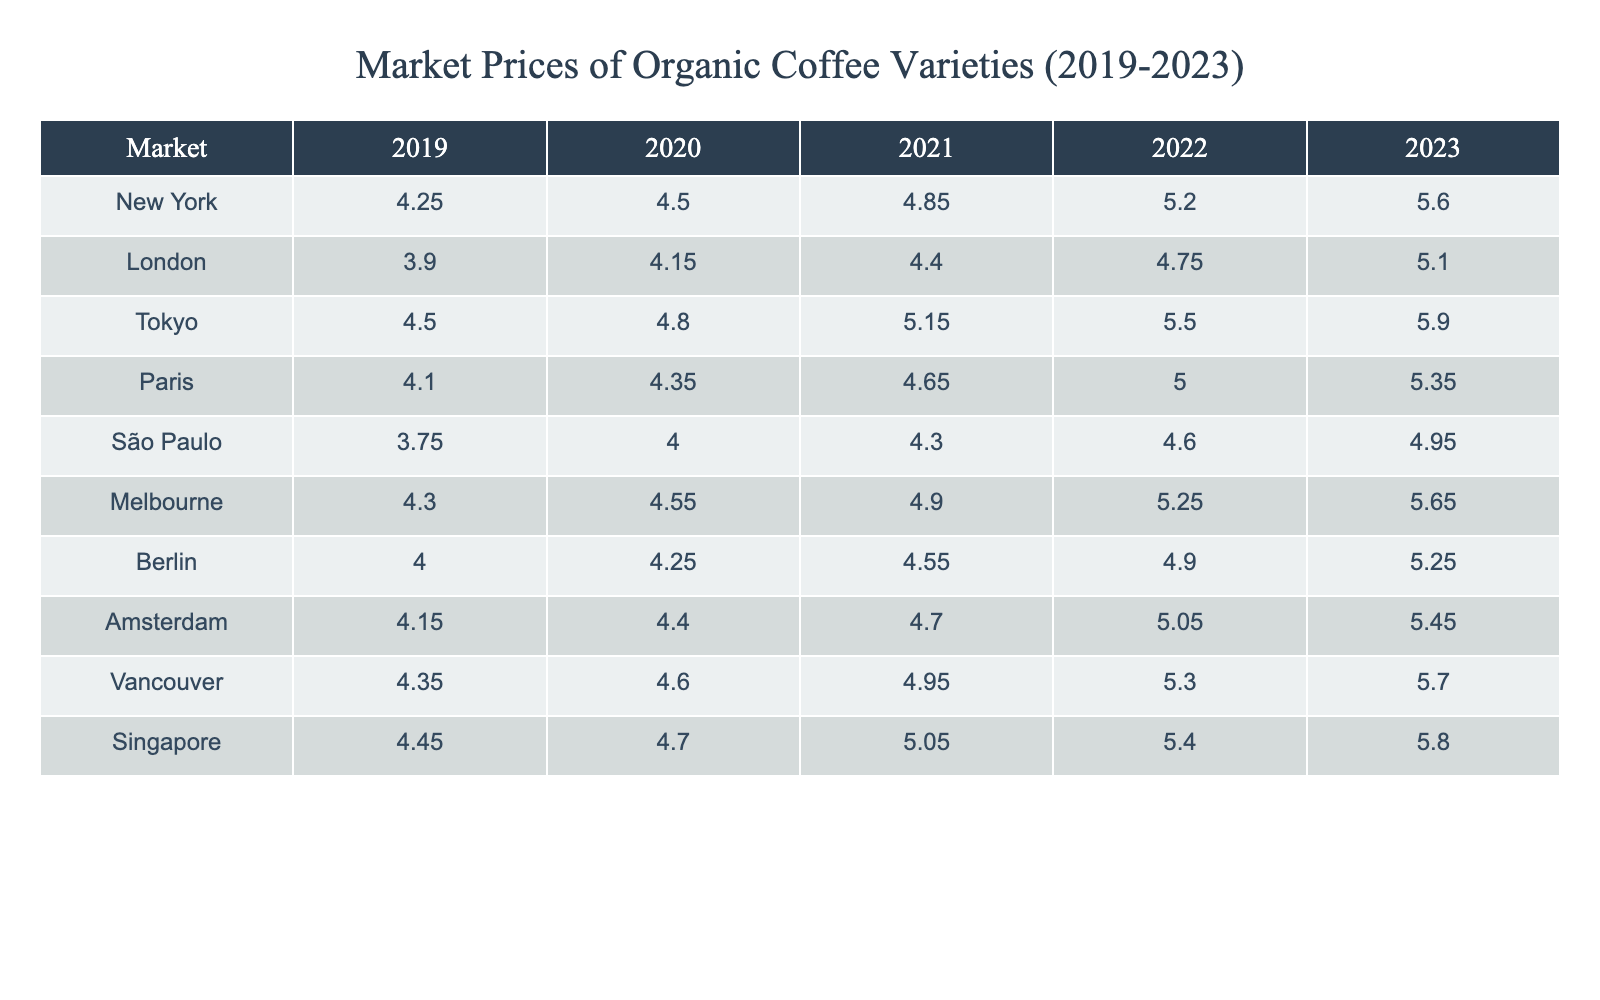What was the market price of organic coffee in New York in 2021? The table shows that the price of organic coffee in New York for the year 2021 is 4.85.
Answer: 4.85 Which market had the highest price for organic coffee in 2023? Looking at the prices for 2023, Tokyo has the highest price at 5.90.
Answer: Tokyo What was the average price of organic coffee in London over the past 5 years? To find the average, sum the prices: (3.90 + 4.15 + 4.40 + 4.75 + 5.10) = 22.30. Then divide by 5: 22.30/5 = 4.46.
Answer: 4.46 Was the price of organic coffee in São Paulo higher in 2022 compared to 2021? The price in 2022 was 4.60 and in 2021 was 4.30. Since 4.60 is greater than 4.30, the statement is true.
Answer: Yes What was the percentage increase in the price of organic coffee in Tokyo from 2019 to 2023? Calculate the increase: 5.90 - 4.50 = 1.40. Then divide by the 2019 price: 1.40/4.50 ≈ 0.3111. Multiply by 100 for percentage: 0.3111 * 100 ≈ 31.11%.
Answer: 31.11% In which year did Berlin see a price of organic coffee below 4.60? The prices for Berlin were 4.00 in 2019, 4.25 in 2020, and 4.55 in 2021, all of which are below 4.60. Hence, those years meet the condition.
Answer: 2019, 2020, 2021 What is the price difference between organic coffee in Melbourne and Amsterdam in 2022? The price in Melbourne in 2022 is 5.25 and in Amsterdam, it is 5.05. The difference is 5.25 - 5.05 = 0.20.
Answer: 0.20 Which market experienced the highest year-over-year growth in organic coffee prices from 2021 to 2022? Calculate the growth: Tokyo (5.50 - 5.15 = 0.35), New York (5.20 - 4.85 = 0.35), and others. Both Tokyo and New York had a growth of 0.35, which is the highest observed.
Answer: Tokyo and New York What was the lowest price over the past 5 years, and which market did it belong to? The lowest price recorded is 3.75 in São Paulo in 2019.
Answer: 3.75, São Paulo How did the prices in Vancouver change from 2019 to 2023? The price in 2019 was 4.35, and in 2023 it is 5.70. Calculate the change: 5.70 - 4.35 = 1.35, indicating an increase over the years.
Answer: Increased by 1.35 